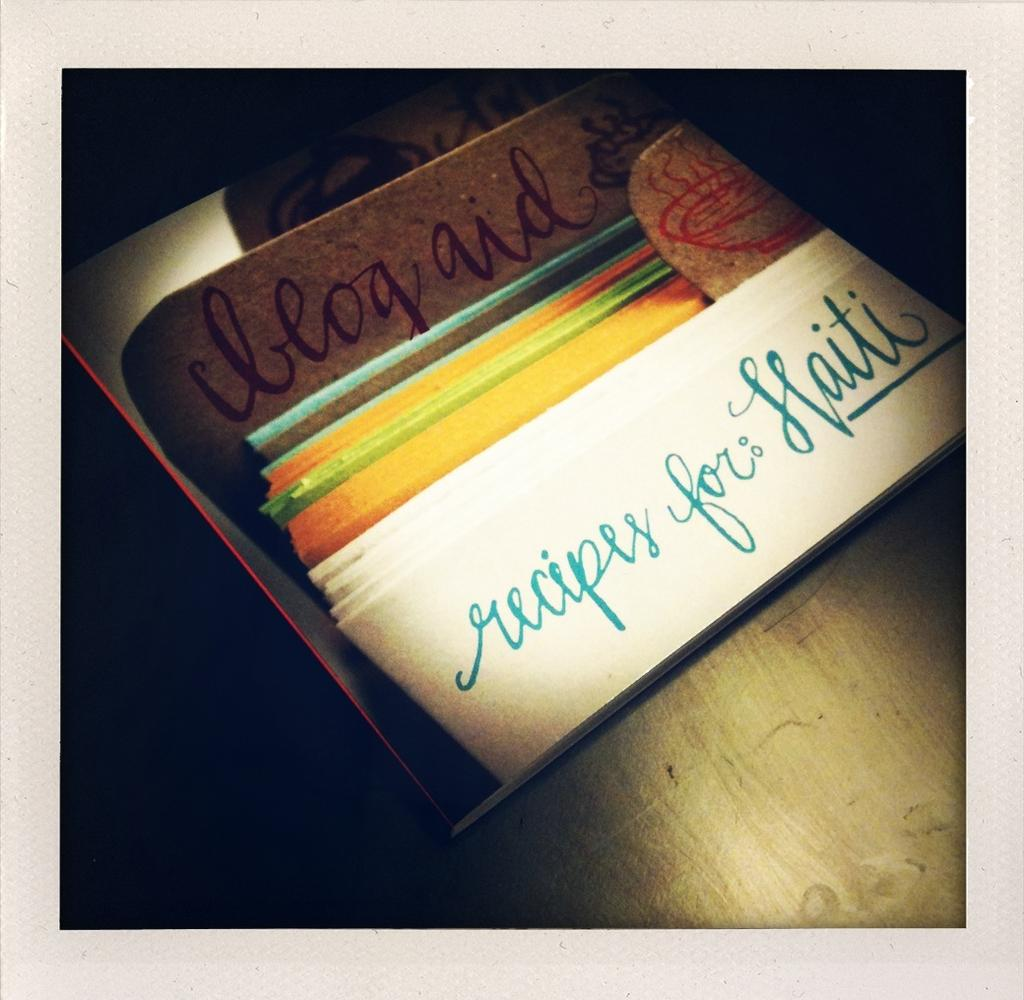Provide a one-sentence caption for the provided image. A book about recipes for Haiti sits on a table in a darkened room. 